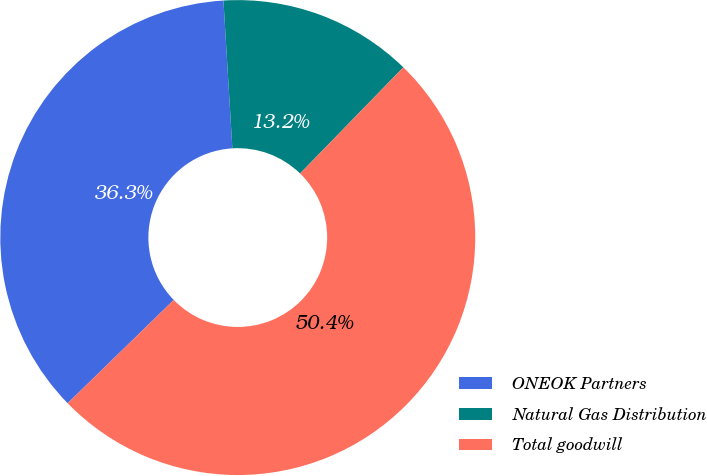<chart> <loc_0><loc_0><loc_500><loc_500><pie_chart><fcel>ONEOK Partners<fcel>Natural Gas Distribution<fcel>Total goodwill<nl><fcel>36.33%<fcel>13.24%<fcel>50.43%<nl></chart> 